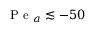<formula> <loc_0><loc_0><loc_500><loc_500>P e _ { a } \lesssim - 5 0</formula> 